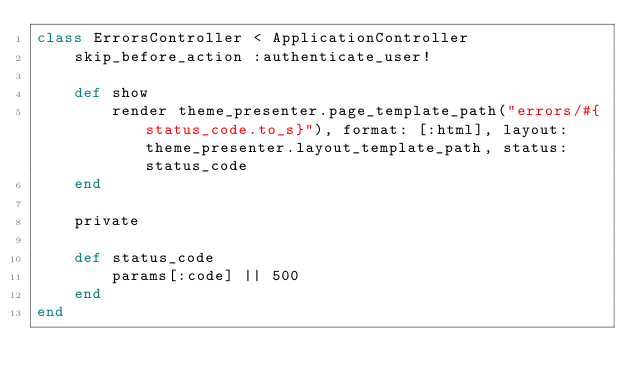<code> <loc_0><loc_0><loc_500><loc_500><_Ruby_>class ErrorsController < ApplicationController
    skip_before_action :authenticate_user!
    
    def show
        render theme_presenter.page_template_path("errors/#{status_code.to_s}"), format: [:html], layout: theme_presenter.layout_template_path, status: status_code
    end

    private

    def status_code
        params[:code] || 500
    end
end</code> 